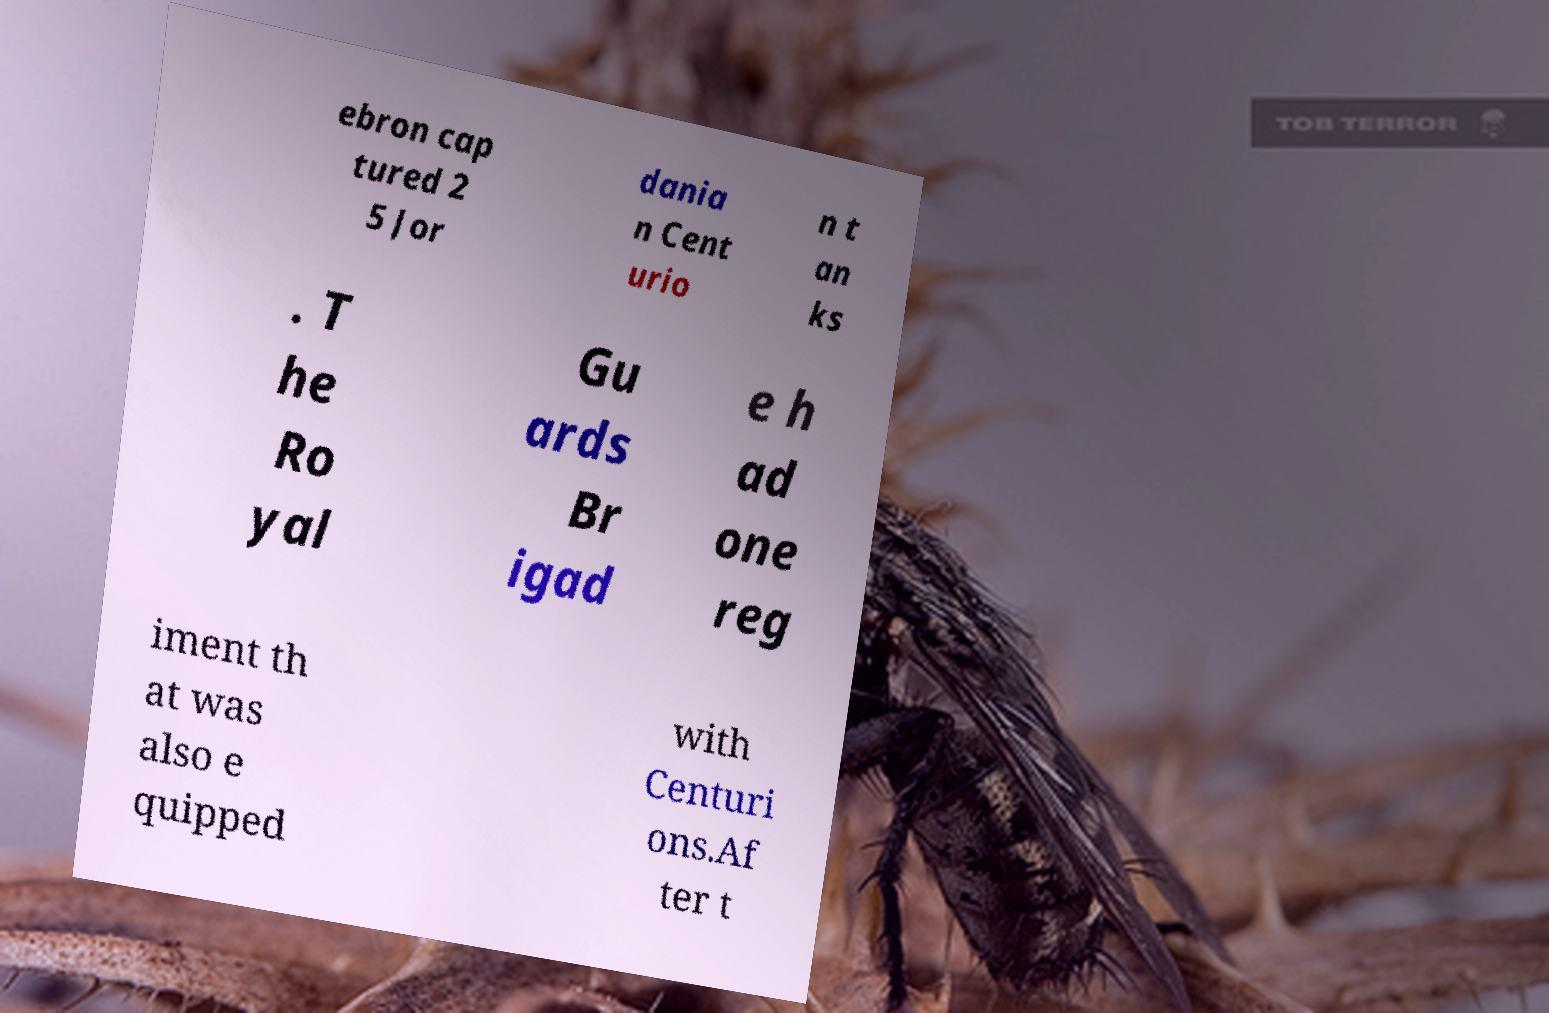Could you extract and type out the text from this image? ebron cap tured 2 5 Jor dania n Cent urio n t an ks . T he Ro yal Gu ards Br igad e h ad one reg iment th at was also e quipped with Centuri ons.Af ter t 